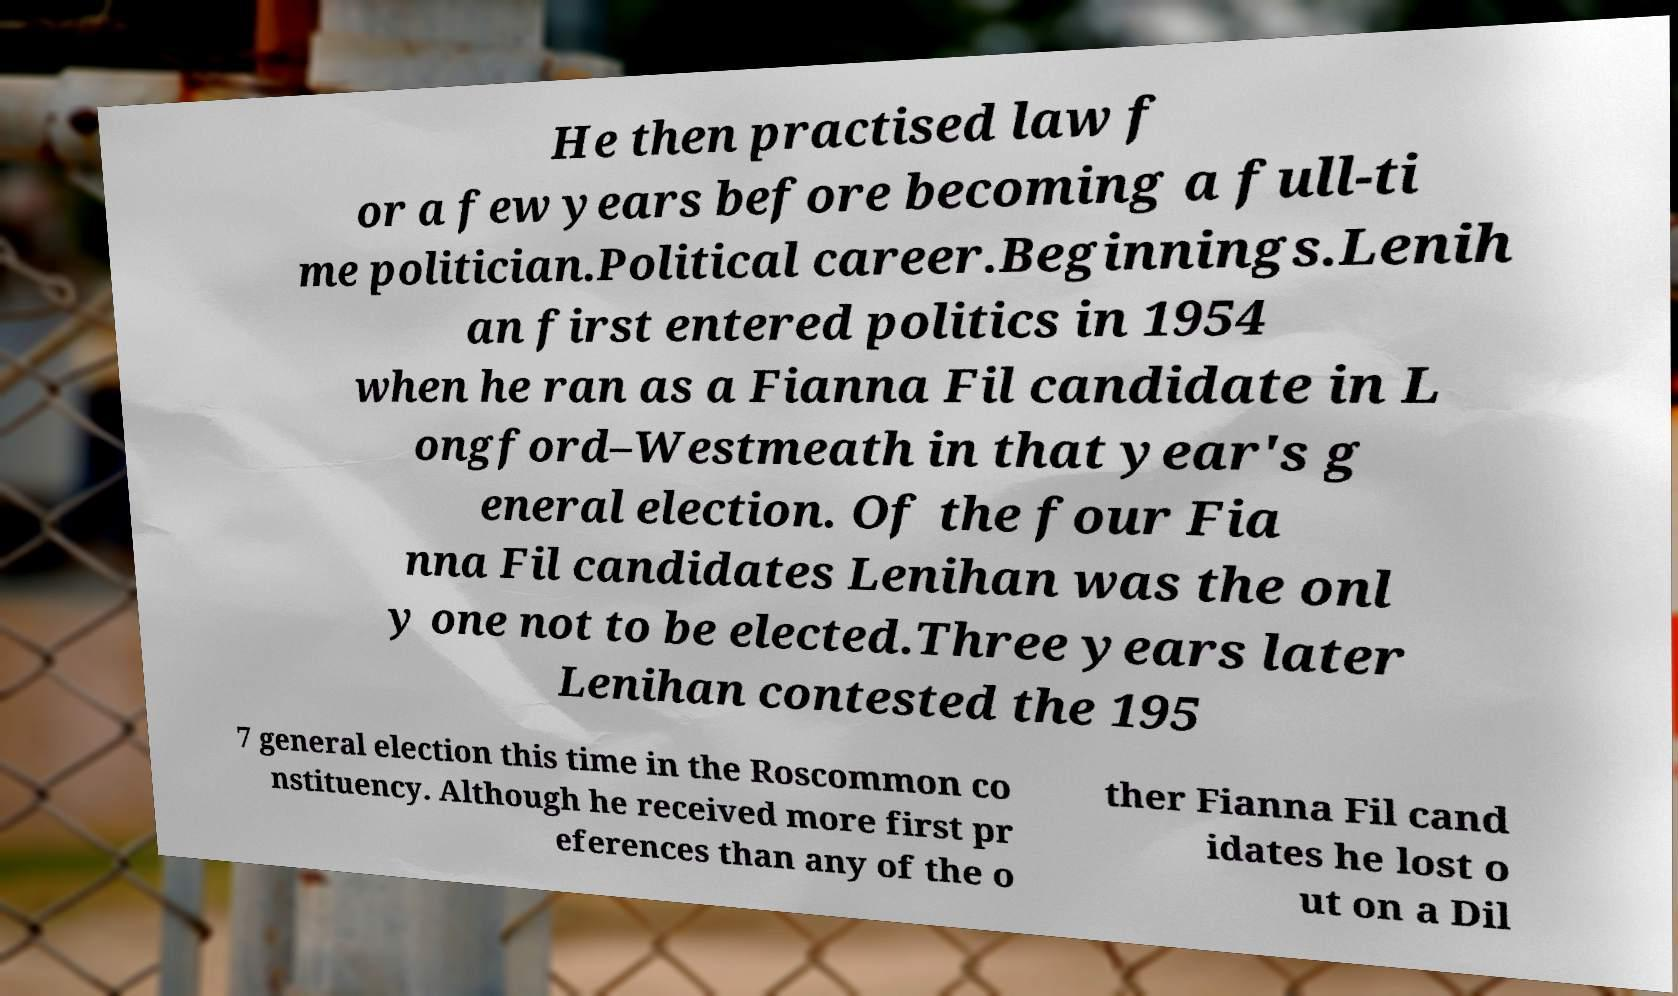Please read and relay the text visible in this image. What does it say? He then practised law f or a few years before becoming a full-ti me politician.Political career.Beginnings.Lenih an first entered politics in 1954 when he ran as a Fianna Fil candidate in L ongford–Westmeath in that year's g eneral election. Of the four Fia nna Fil candidates Lenihan was the onl y one not to be elected.Three years later Lenihan contested the 195 7 general election this time in the Roscommon co nstituency. Although he received more first pr eferences than any of the o ther Fianna Fil cand idates he lost o ut on a Dil 